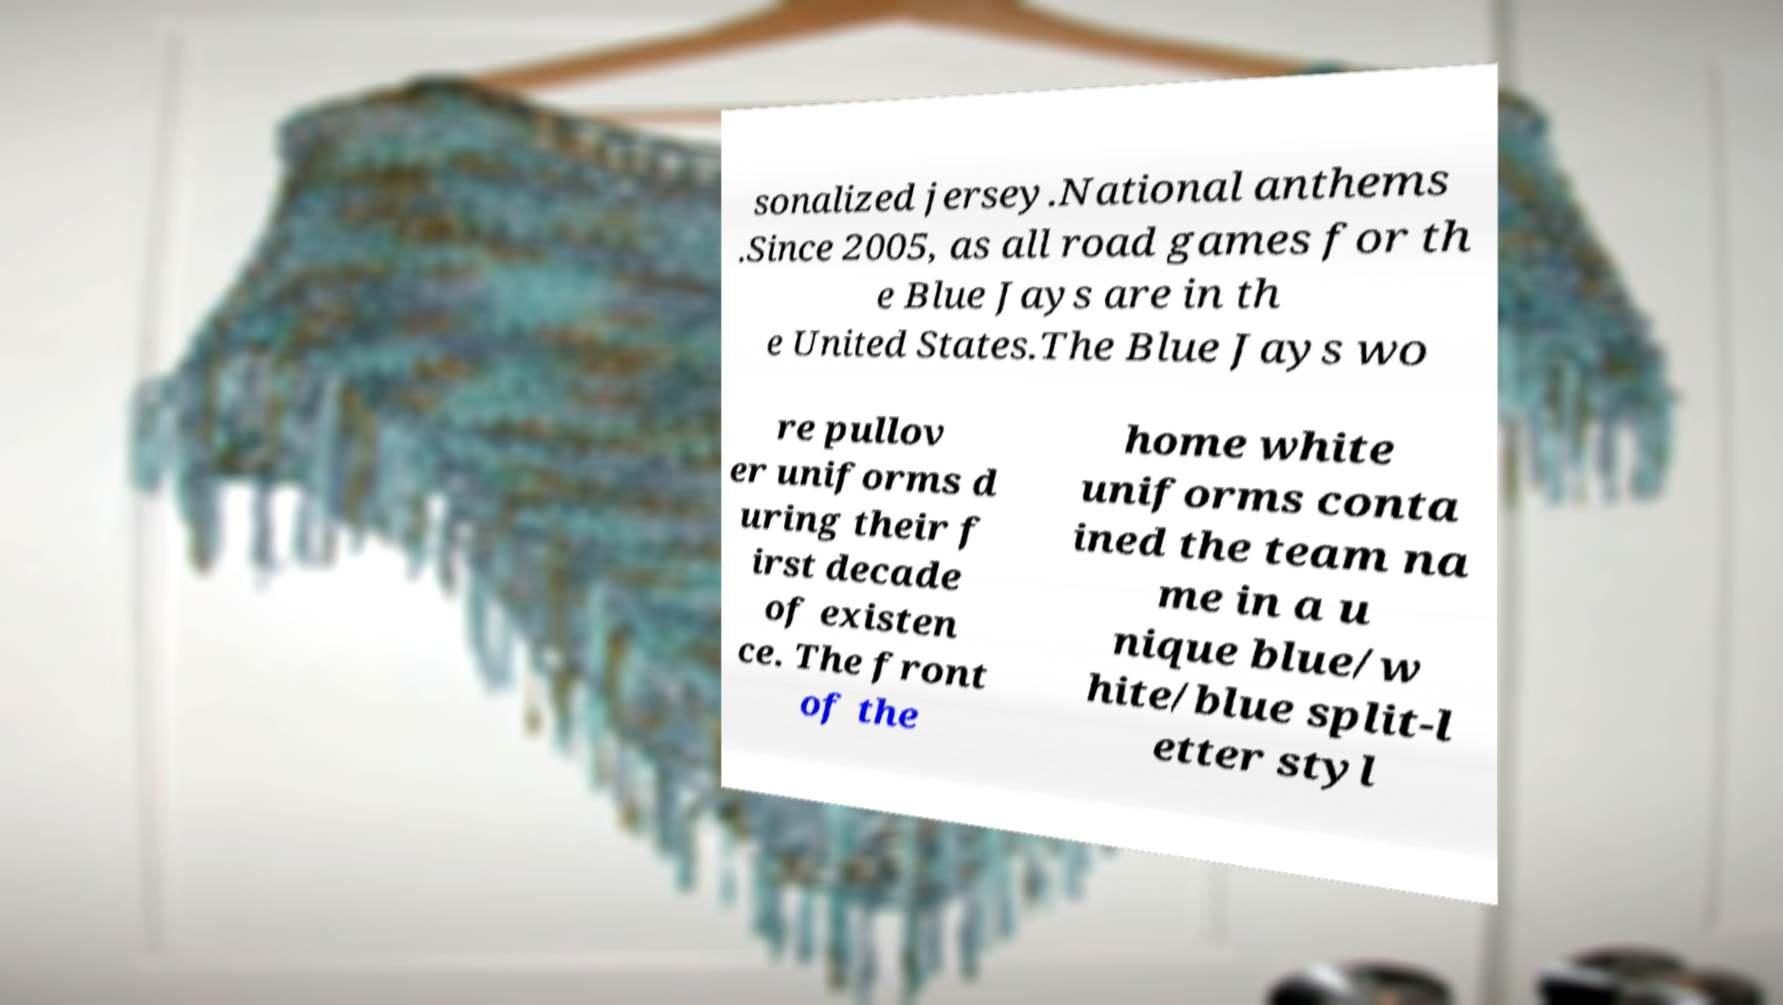Could you assist in decoding the text presented in this image and type it out clearly? sonalized jersey.National anthems .Since 2005, as all road games for th e Blue Jays are in th e United States.The Blue Jays wo re pullov er uniforms d uring their f irst decade of existen ce. The front of the home white uniforms conta ined the team na me in a u nique blue/w hite/blue split-l etter styl 